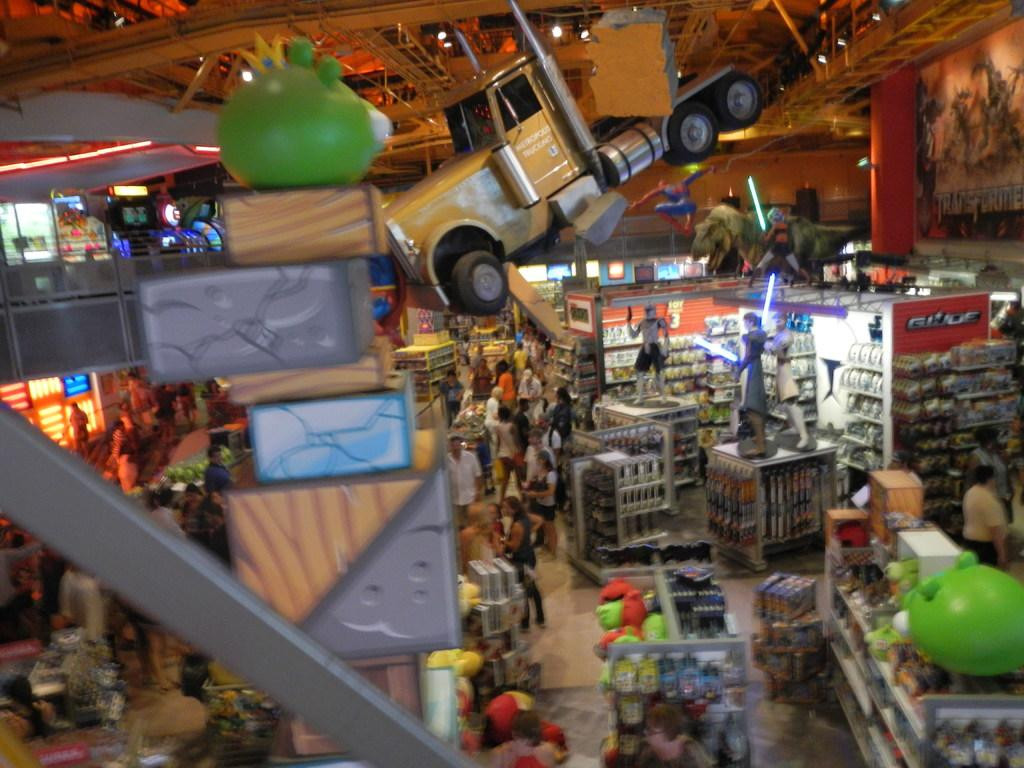What are the people in the image wearing? The people in the image are wearing clothes. What are the people in the image doing? The people are standing. What type of objects can be seen in the image besides people? There are toys, a toy truck, a pillar, a poster, and a sculpture of people in the image. What is the setting of the image? There is a floor in the image, which suggests it is an indoor setting. What type of light source is visible in the image? There is a light in the image. What type of weather can be seen in the image? The image does not depict any weather conditions; it is an indoor setting with a light source. Is there a judge present in the image? There is no judge present in the image. 